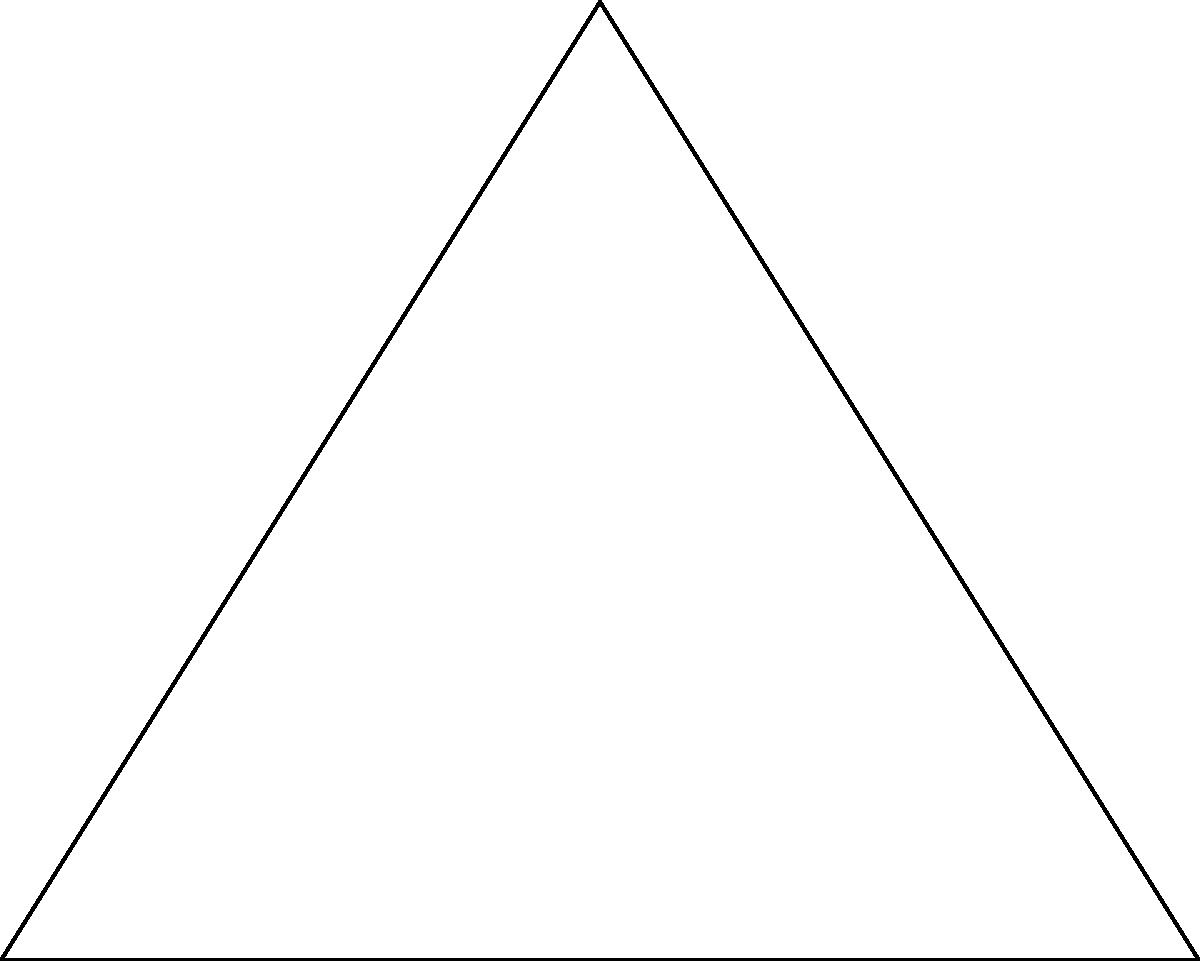During a Bethune-Cookman Wildcats basketball game, Player A is positioned at one corner of the court, Player B is 40 feet away along the sideline, and Player C is somewhere on the court. The angle between Player A and Player C (with Player B at the vertex) is 30°, while the angle between Player B and Player C (with Player A at the vertex) is 60°. Using trigonometric functions, calculate the distance between Player A and Player C to the nearest foot. Let's approach this step-by-step using the law of sines:

1) First, let's define our triangle:
   - Side c (AB) = 40 feet
   - Angle C = 90° (right angle)
   - Angle B = 30°
   - Angle A = 60°

2) We want to find side a (BC). We can use the law of sines:

   $$\frac{a}{\sin A} = \frac{b}{\sin B} = \frac{c}{\sin C}$$

3) We know c and all angles, so let's use:

   $$\frac{a}{\sin 60°} = \frac{40}{\sin 90°}$$

4) Simplify:
   $$\frac{a}{\frac{\sqrt{3}}{2}} = \frac{40}{1}$$

5) Cross multiply:
   $$a * 1 = 40 * \frac{\sqrt{3}}{2}$$

6) Solve for a:
   $$a = 40 * \frac{\sqrt{3}}{2} = 20\sqrt{3} \approx 34.64$$

7) Round to the nearest foot:
   $$a \approx 35 \text{ feet}$$

Thus, the distance between Player A and Player C is approximately 35 feet.
Answer: 35 feet 